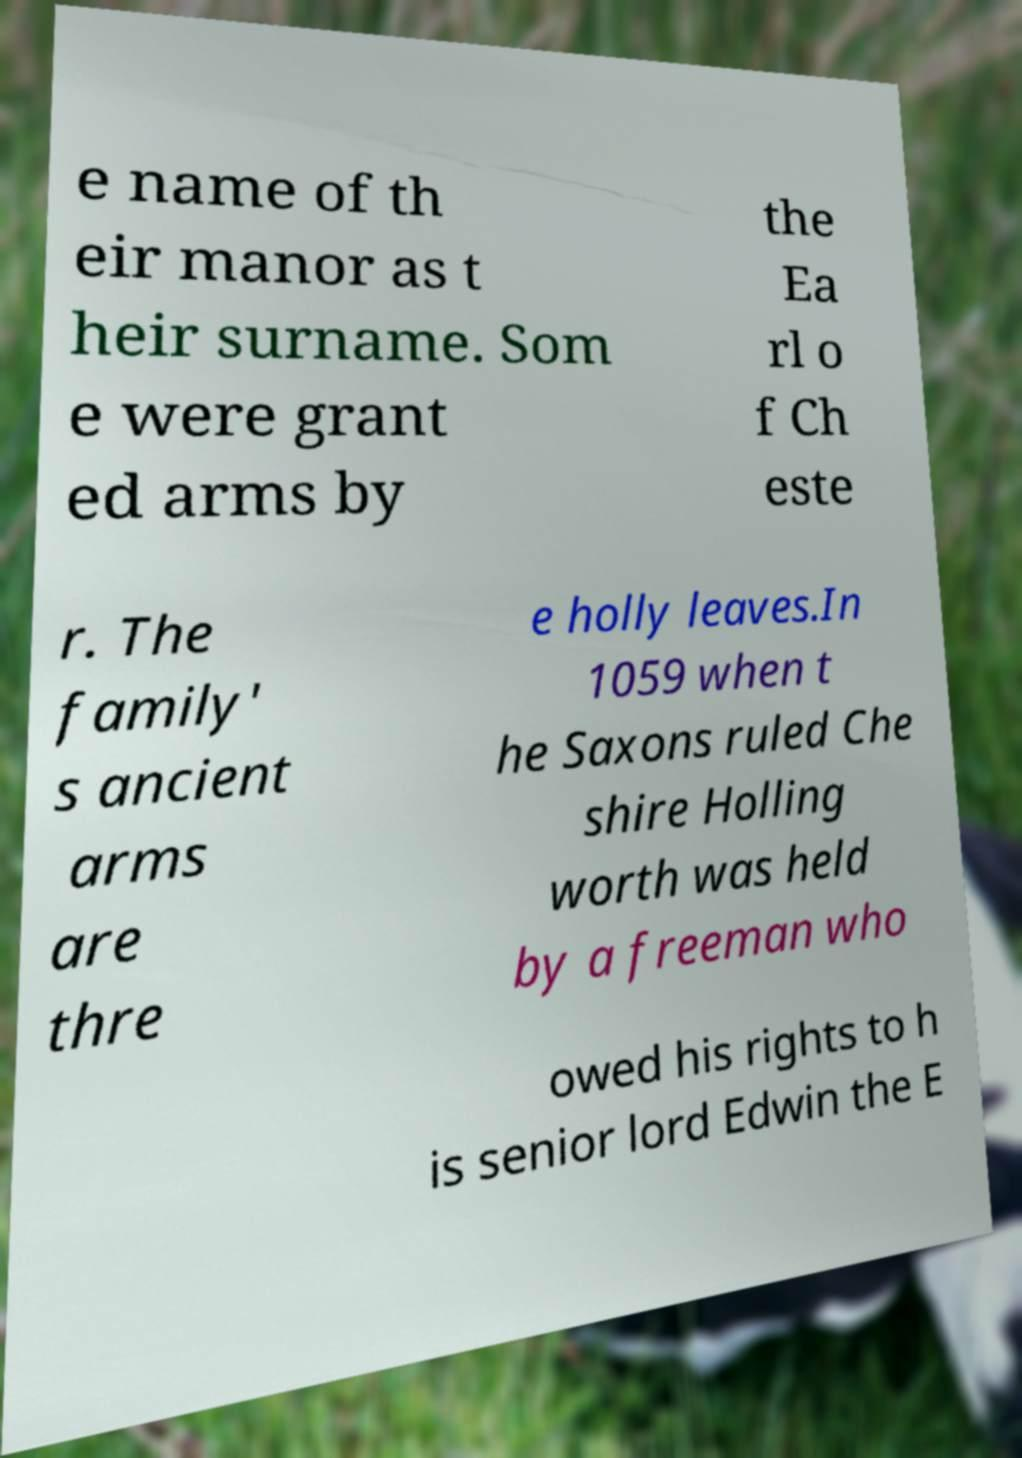Please read and relay the text visible in this image. What does it say? e name of th eir manor as t heir surname. Som e were grant ed arms by the Ea rl o f Ch este r. The family' s ancient arms are thre e holly leaves.In 1059 when t he Saxons ruled Che shire Holling worth was held by a freeman who owed his rights to h is senior lord Edwin the E 